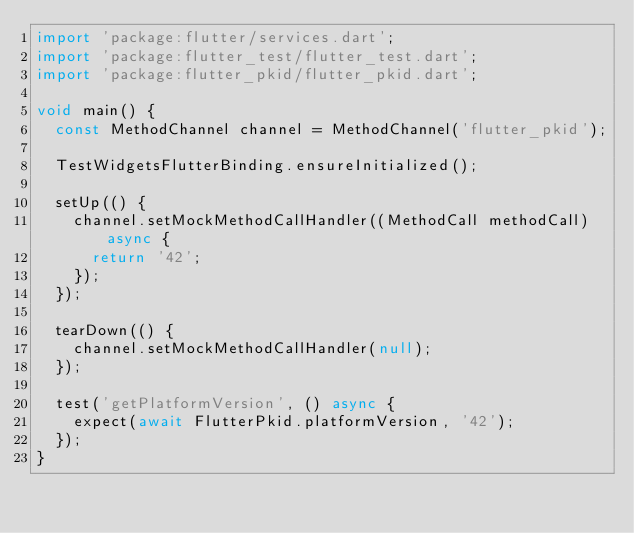Convert code to text. <code><loc_0><loc_0><loc_500><loc_500><_Dart_>import 'package:flutter/services.dart';
import 'package:flutter_test/flutter_test.dart';
import 'package:flutter_pkid/flutter_pkid.dart';

void main() {
  const MethodChannel channel = MethodChannel('flutter_pkid');

  TestWidgetsFlutterBinding.ensureInitialized();

  setUp(() {
    channel.setMockMethodCallHandler((MethodCall methodCall) async {
      return '42';
    });
  });

  tearDown(() {
    channel.setMockMethodCallHandler(null);
  });

  test('getPlatformVersion', () async {
    expect(await FlutterPkid.platformVersion, '42');
  });
}
</code> 